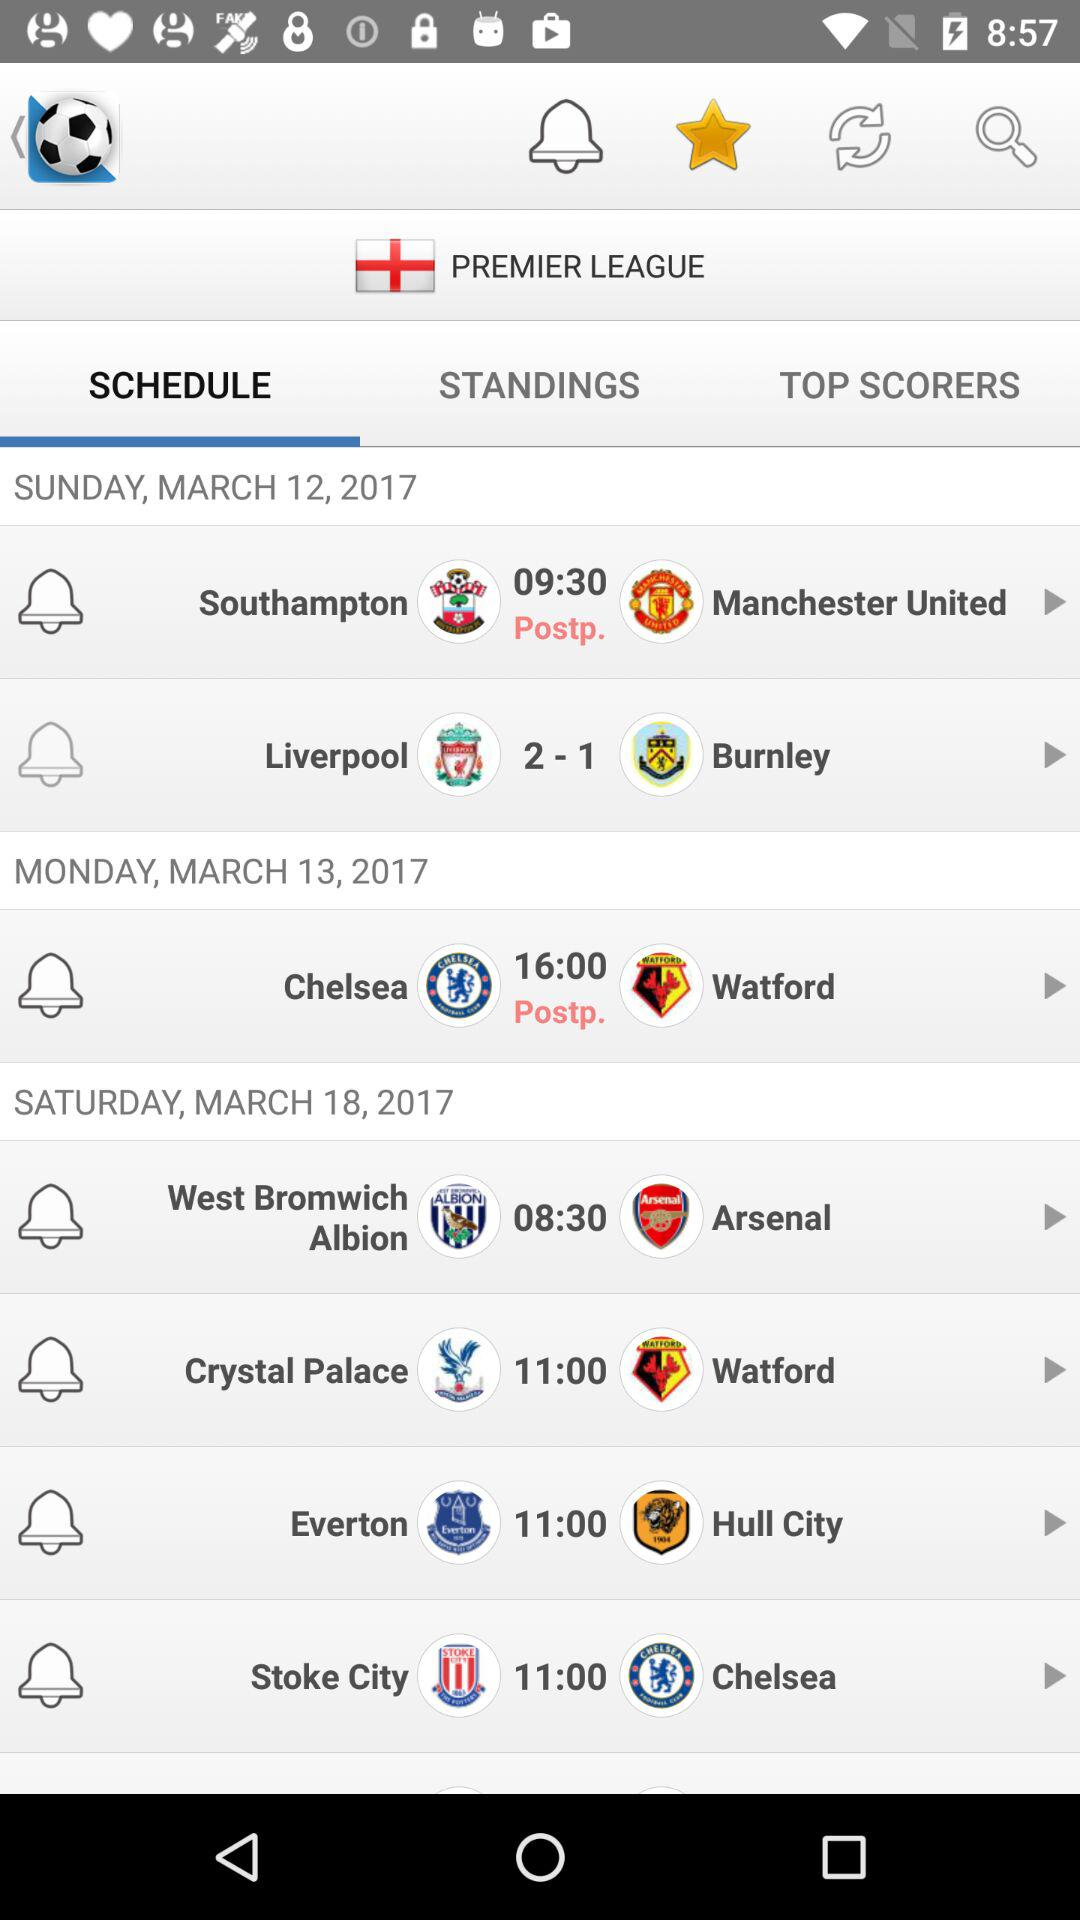How many more days are there between the first and second match?
Answer the question using a single word or phrase. 1 